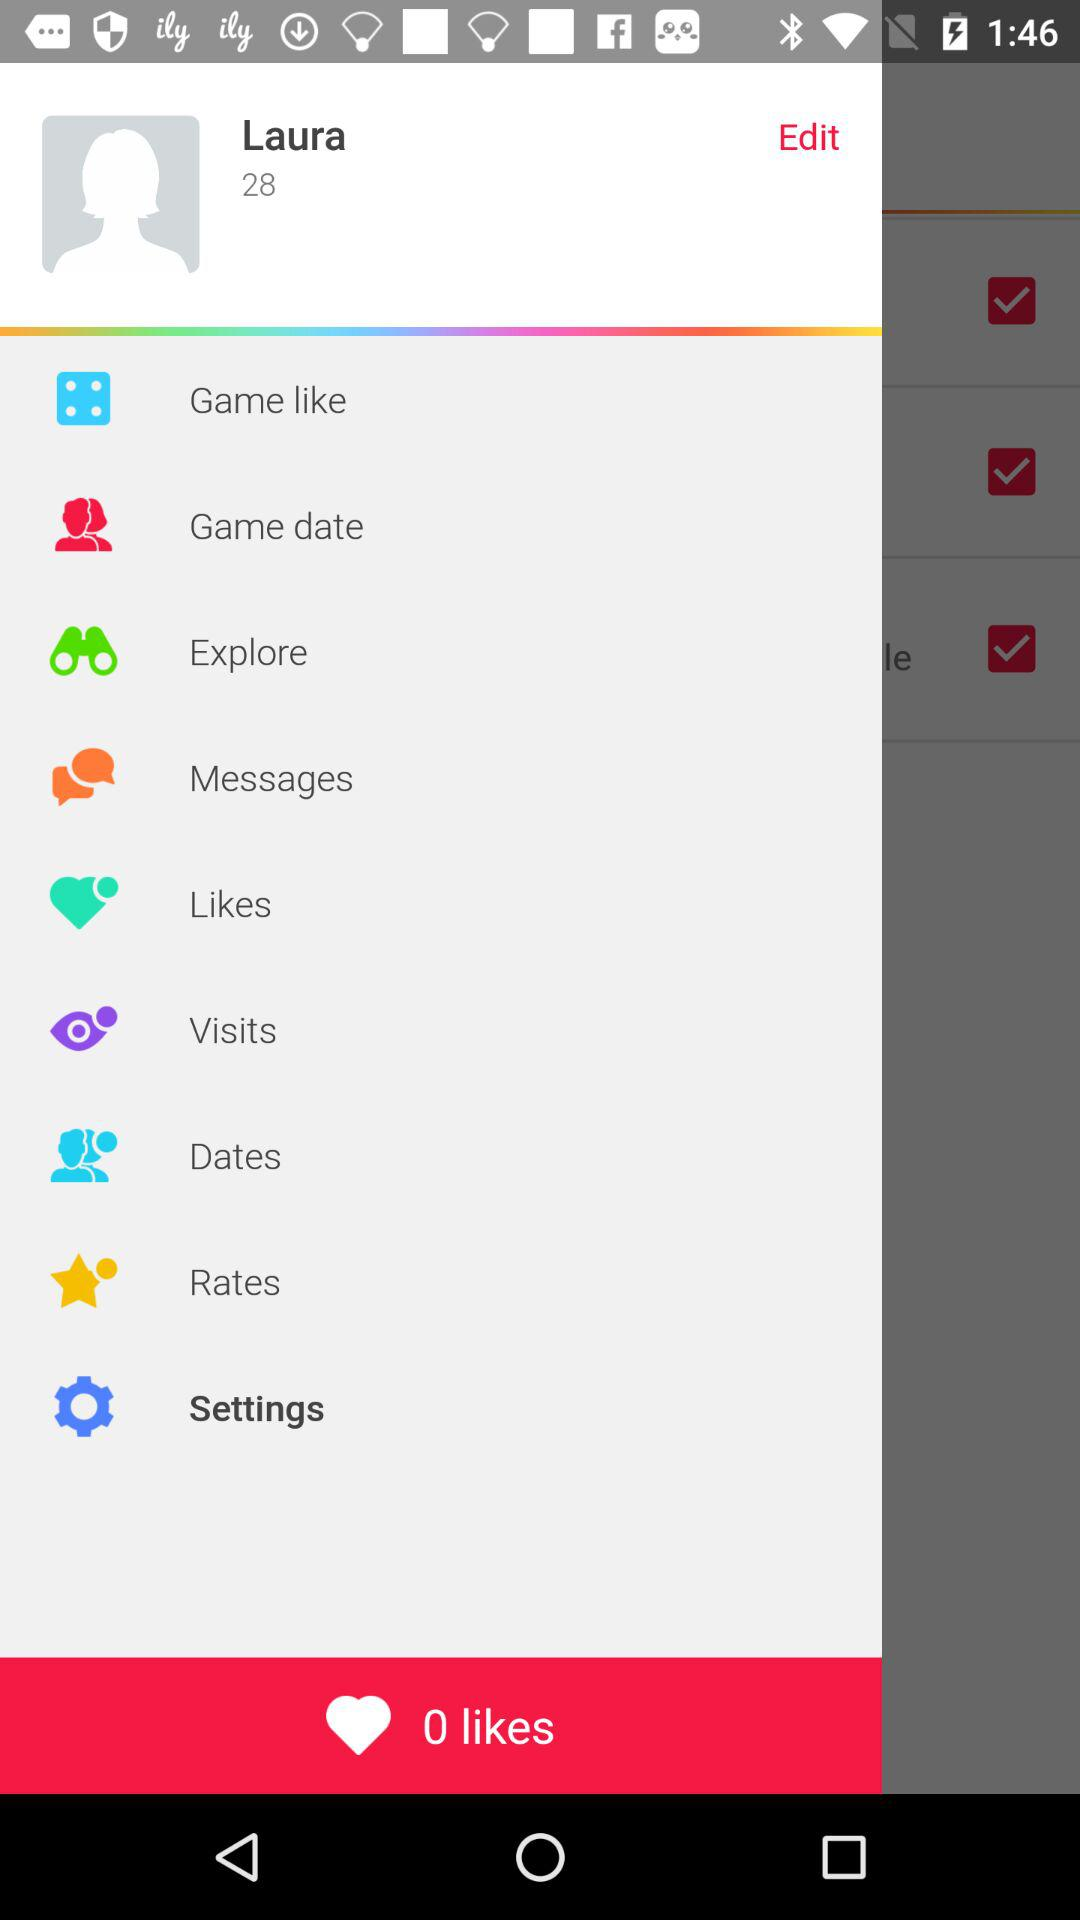What is the number of likes? The number of likes is 0. 